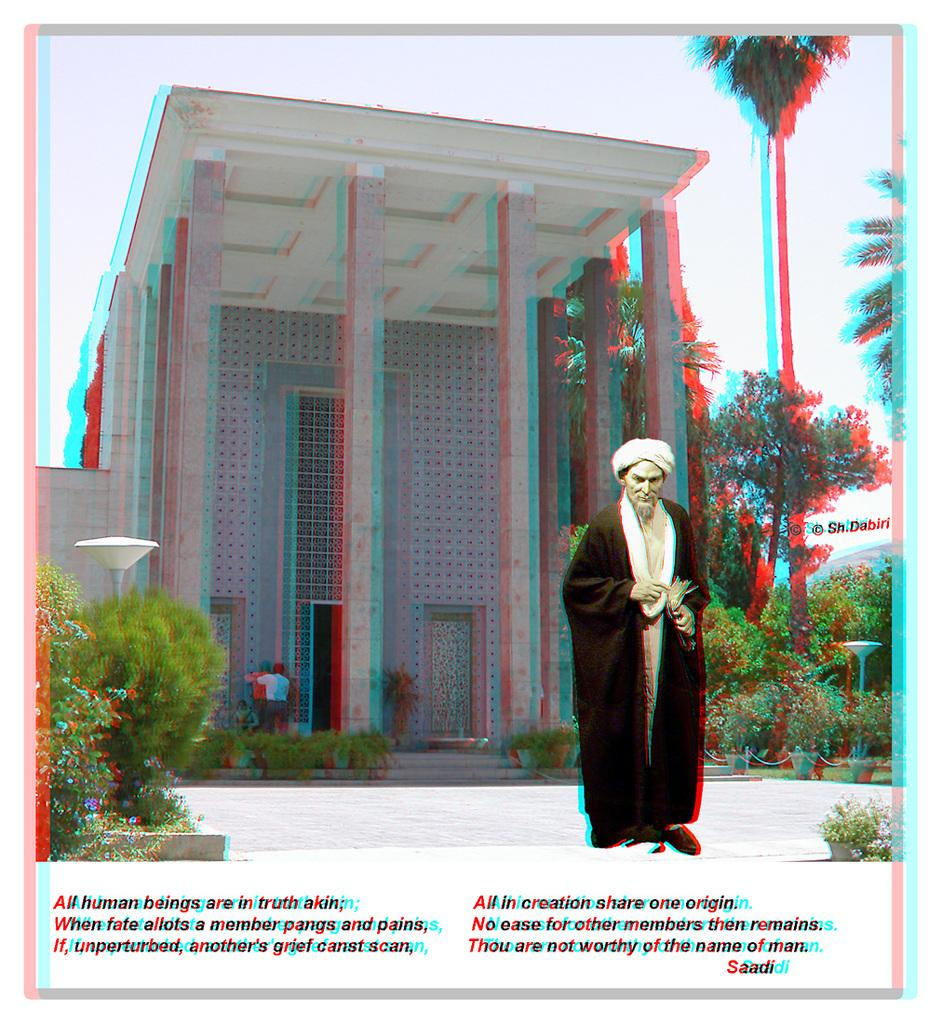What is the main subject of the image? There is a man standing in the image. What can be seen in the background of the image? There is a building, people, trees, plants, and the sky visible in the background of the image. Is there any text or writing in the image? Yes, there is something written on the image. What type of haircut does the maid have in the image? There is no maid present in the image, and therefore no haircut to describe. What is the cause of the loss experienced by the people in the image? There is no indication of any loss experienced by the people in the image. 